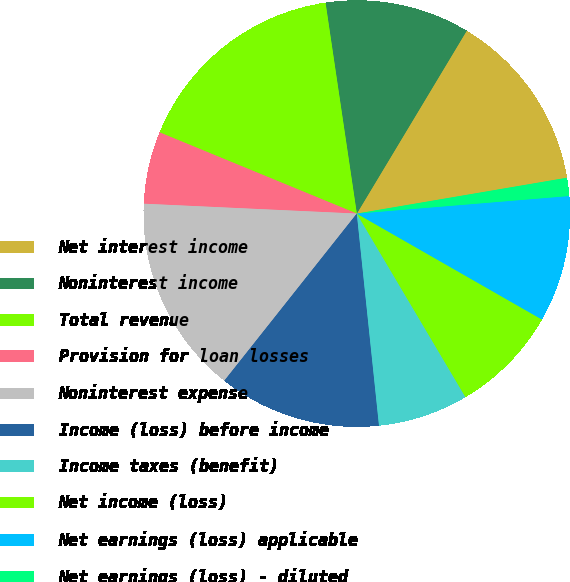Convert chart. <chart><loc_0><loc_0><loc_500><loc_500><pie_chart><fcel>Net interest income<fcel>Noninterest income<fcel>Total revenue<fcel>Provision for loan losses<fcel>Noninterest expense<fcel>Income (loss) before income<fcel>Income taxes (benefit)<fcel>Net income (loss)<fcel>Net earnings (loss) applicable<fcel>Net earnings (loss) - diluted<nl><fcel>13.7%<fcel>10.96%<fcel>16.44%<fcel>5.48%<fcel>15.07%<fcel>12.33%<fcel>6.85%<fcel>8.22%<fcel>9.59%<fcel>1.37%<nl></chart> 